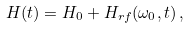Convert formula to latex. <formula><loc_0><loc_0><loc_500><loc_500>H ( t ) = H _ { 0 } + H _ { r f } ( \omega _ { 0 } , t ) \, ,</formula> 